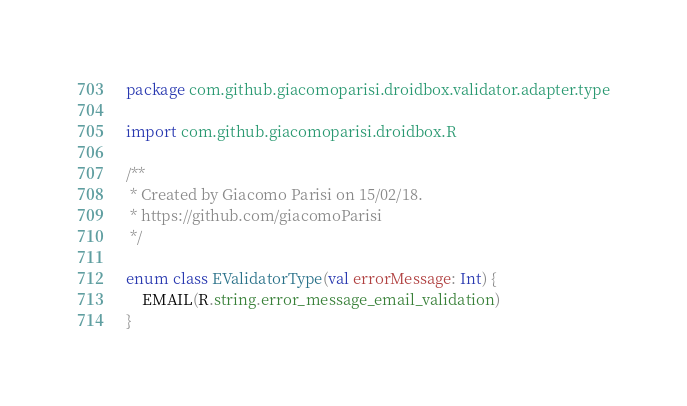<code> <loc_0><loc_0><loc_500><loc_500><_Kotlin_>package com.github.giacomoparisi.droidbox.validator.adapter.type

import com.github.giacomoparisi.droidbox.R

/**
 * Created by Giacomo Parisi on 15/02/18.
 * https://github.com/giacomoParisi
 */

enum class EValidatorType(val errorMessage: Int) {
    EMAIL(R.string.error_message_email_validation)
}</code> 